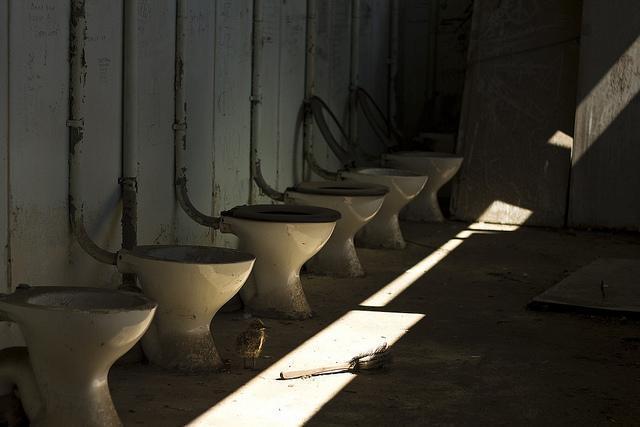How many toilets are there?
Give a very brief answer. 6. How many cups are hanged up?
Give a very brief answer. 0. How many dogs are standing in boat?
Give a very brief answer. 0. 